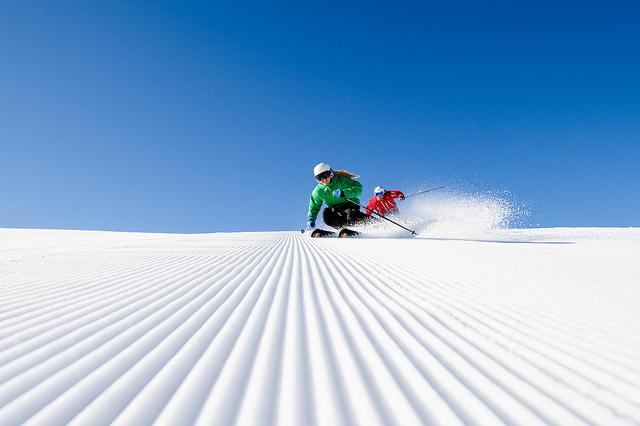What are the people doing?
Keep it brief. Skiing. How many people are in this photo?
Be succinct. 2. Is the snow smooth?
Be succinct. No. 